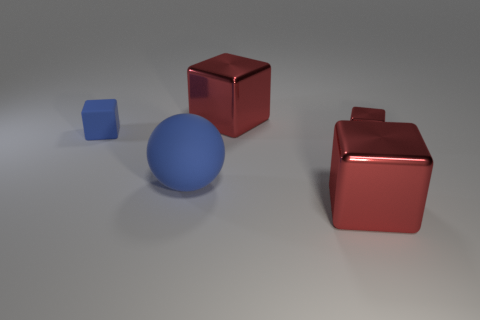Subtract all yellow cylinders. How many red cubes are left? 3 Add 4 metal cubes. How many objects exist? 9 Subtract all green blocks. Subtract all purple balls. How many blocks are left? 4 Subtract all spheres. How many objects are left? 4 Subtract all blue cubes. Subtract all matte cubes. How many objects are left? 3 Add 3 big blue rubber spheres. How many big blue rubber spheres are left? 4 Add 4 small blue cubes. How many small blue cubes exist? 5 Subtract 0 red cylinders. How many objects are left? 5 